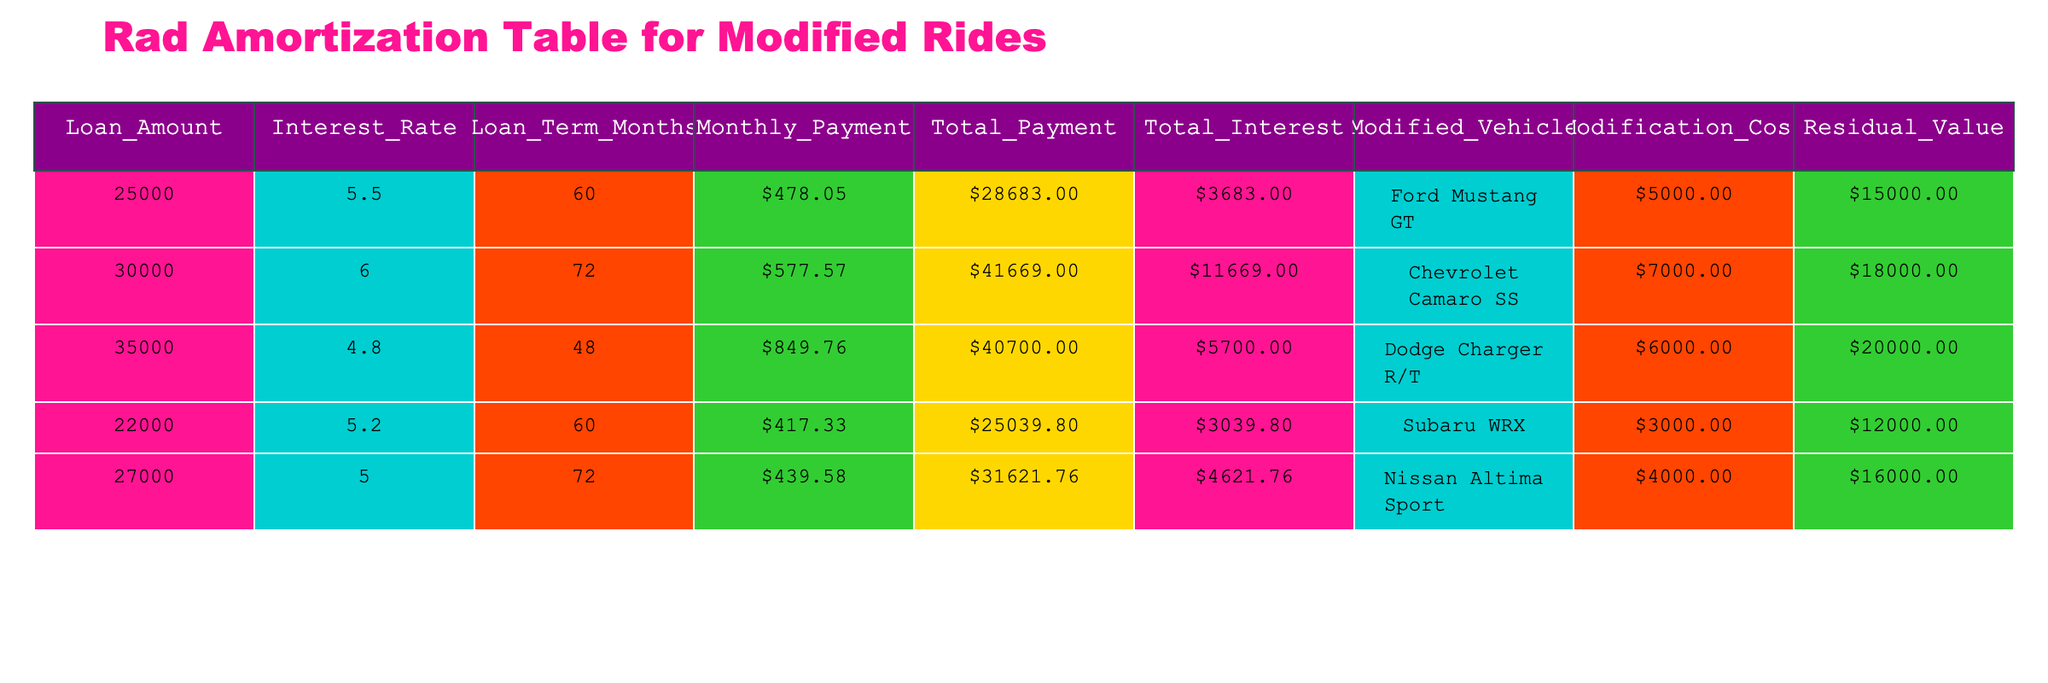What is the loan amount for the Ford Mustang GT? The loan amount is directly listed under the "Loan_Amount" column for the "Ford Mustang GT" row in the table. It shows 25000.
Answer: 25000 What is the total interest paid for the Chevrolet Camaro SS? The total interest is listed in the "Total_Interest" column corresponding to the "Chevrolet Camaro SS" row, which indicates 11669.
Answer: 11669 Does the Nissan Altima Sport have a residual value greater than 15000? By checking the "Residual_Value" column for the "Nissan Altima Sport" row, I see that the value is 16000, which is indeed greater than 15000.
Answer: Yes What is the average monthly payment for all the vehicles listed? To find the average, sum all the "Monthly_Payment" values: (478.05 + 577.57 + 849.76 + 417.33 + 439.58) = 2762.29. Then divide by the number of vehicles (5), which results in 2762.29 / 5 = 552.46.
Answer: 552.46 What is the difference in total payment between the Dodge Charger R/T and the Subaru WRX? Looking at the "Total_Payment" for the "Dodge Charger R/T" (40700.00) and the "Subaru WRX" (25039.80), the difference is calculated as 40700.00 - 25039.80 = 15660.20.
Answer: 15660.20 Which car modification has the highest modification cost? The "Modification_Cost" column indicates that the "Chevrolet Camaro SS" has the highest cost at 7000. Comparing this value with others confirms it is the largest.
Answer: Chevrolet Camaro SS What is the total payment for the modified vehicles excluding the lowest payment? The "Total_Payment" values are 28683.00, 41669.00, 40700.00, 25039.80, and 31621.76. Excluding the lowest payment (25039.80), the total is 28683 + 41669 + 40700 + 31621.76 = 142173.76.
Answer: 142173.76 Is the total interest paid more than 5000 for the modified vehicle with the least loan amount? The vehicle with the least "Loan_Amount" is the "Subaru WRX," with a "Total_Interest" of 3039.80, which is less than 5000, confirming the statement as false.
Answer: No 